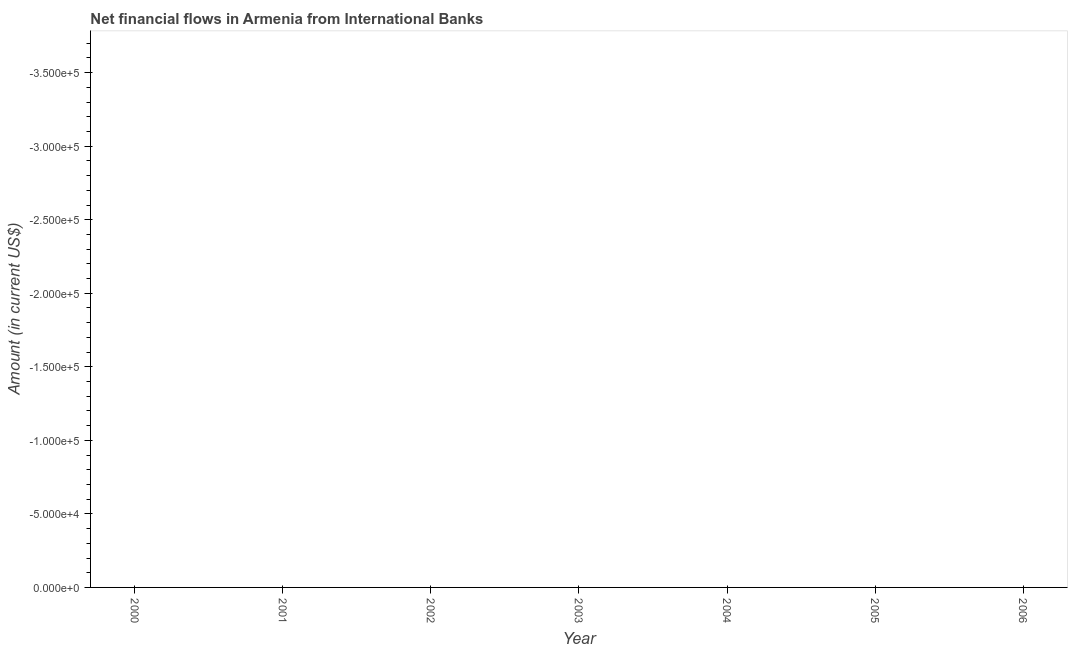Across all years, what is the minimum net financial flows from ibrd?
Offer a terse response. 0. In how many years, is the net financial flows from ibrd greater than -120000 US$?
Offer a very short reply. 0. In how many years, is the net financial flows from ibrd greater than the average net financial flows from ibrd taken over all years?
Your response must be concise. 0. Does the net financial flows from ibrd monotonically increase over the years?
Give a very brief answer. No. Does the graph contain grids?
Give a very brief answer. No. What is the title of the graph?
Your answer should be compact. Net financial flows in Armenia from International Banks. What is the Amount (in current US$) in 2000?
Give a very brief answer. 0. What is the Amount (in current US$) in 2001?
Your response must be concise. 0. What is the Amount (in current US$) in 2006?
Make the answer very short. 0. 